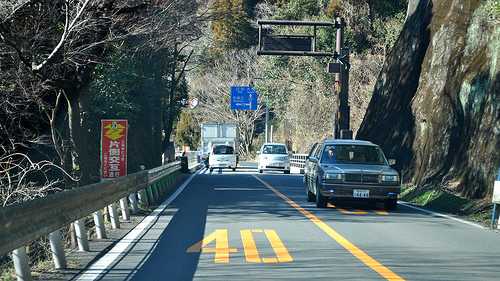<image>
Is the road to the right of the sign? Yes. From this viewpoint, the road is positioned to the right side relative to the sign. Is there a road sign above the guard rail? Yes. The road sign is positioned above the guard rail in the vertical space, higher up in the scene. 